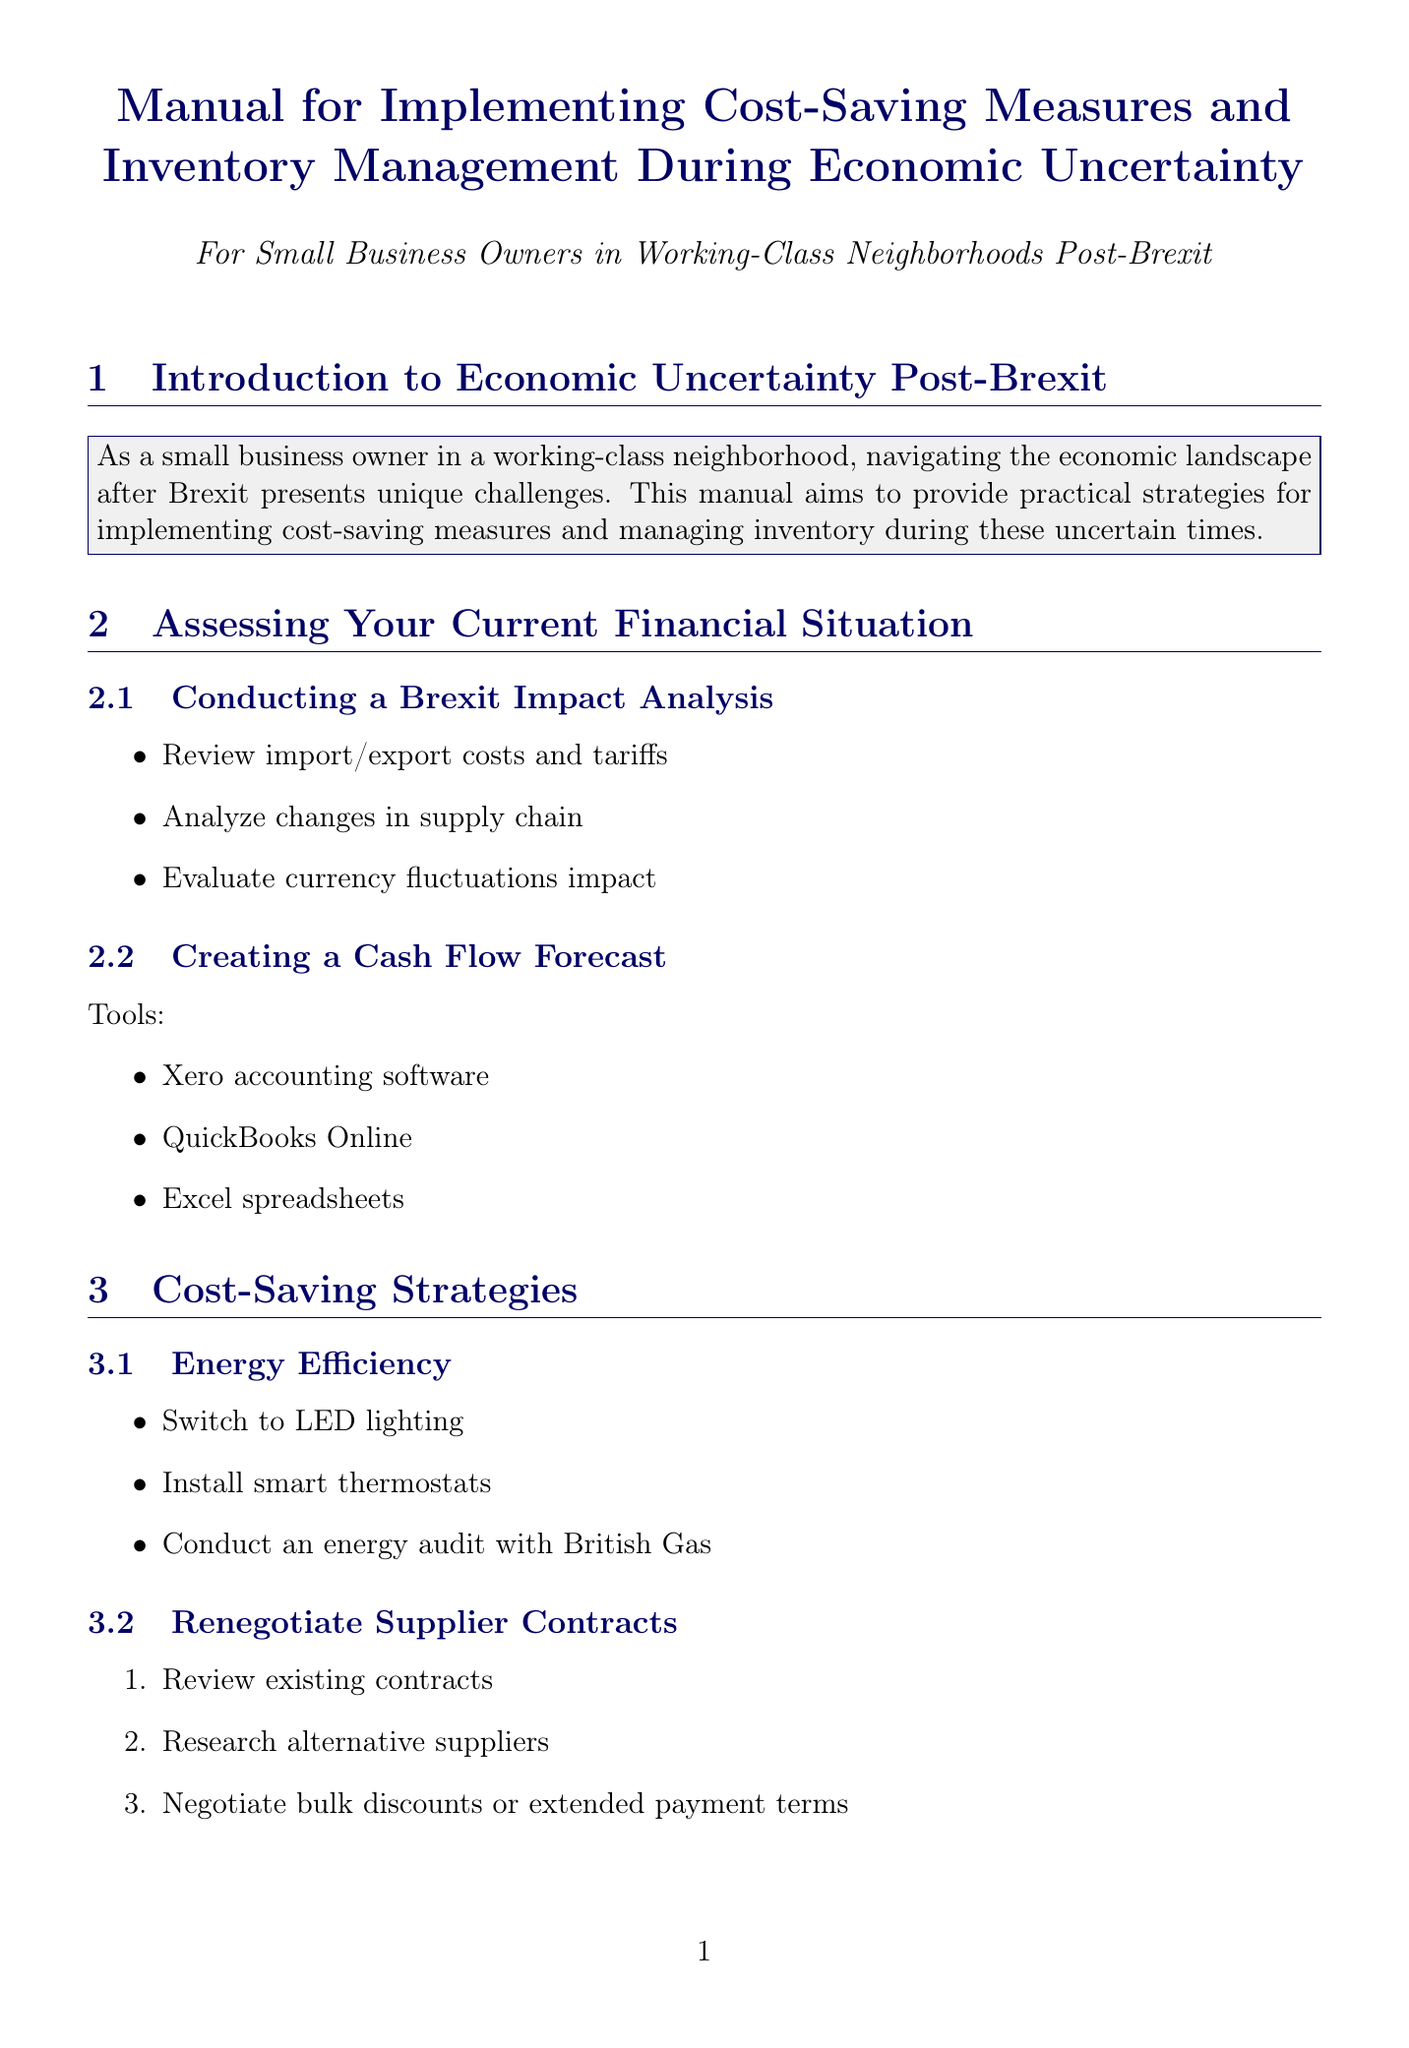What is the primary aim of this manual? The manual provides practical strategies for implementing cost-saving measures and managing inventory during economic uncertainty.
Answer: practical strategies What tool can be used for creating a cash flow forecast? The manual lists several tools for cash flow forecasting, including Xero accounting software.
Answer: Xero accounting software Which energy-saving action is suggested in the document? The document recommends switching to LED lighting as an energy-saving action.
Answer: Switch to LED lighting What is one risk associated with Just-in-Time (JIT) Inventory? The document outlines that a risk of JIT Inventory is the increased risk of stockouts.
Answer: Increased risk of stockouts What type of funding option is CBILS? The document describes CBILS as a loan scheme provided by the British Business Bank.
Answer: loan scheme What is a suggested method to improve staffing efficiencies? The manual mentions implementing flexible working hours as a strategy to optimize staffing.
Answer: Implement flexible working hours What is the main focus of ABC Analysis? The ABC Analysis method focuses on managing high-value items in inventory.
Answer: managing high-value items Which organization provides Brexit advice according to the document? The Federation of Small Businesses is mentioned as providing Brexit advice.
Answer: Federation of Small Businesses What is one example of diversifying product offerings? The document suggests expanding into e-commerce as a way to diversify offerings.
Answer: Expand into e-commerce 